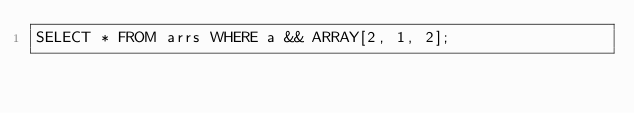Convert code to text. <code><loc_0><loc_0><loc_500><loc_500><_SQL_>SELECT * FROM arrs WHERE a && ARRAY[2, 1, 2];
</code> 